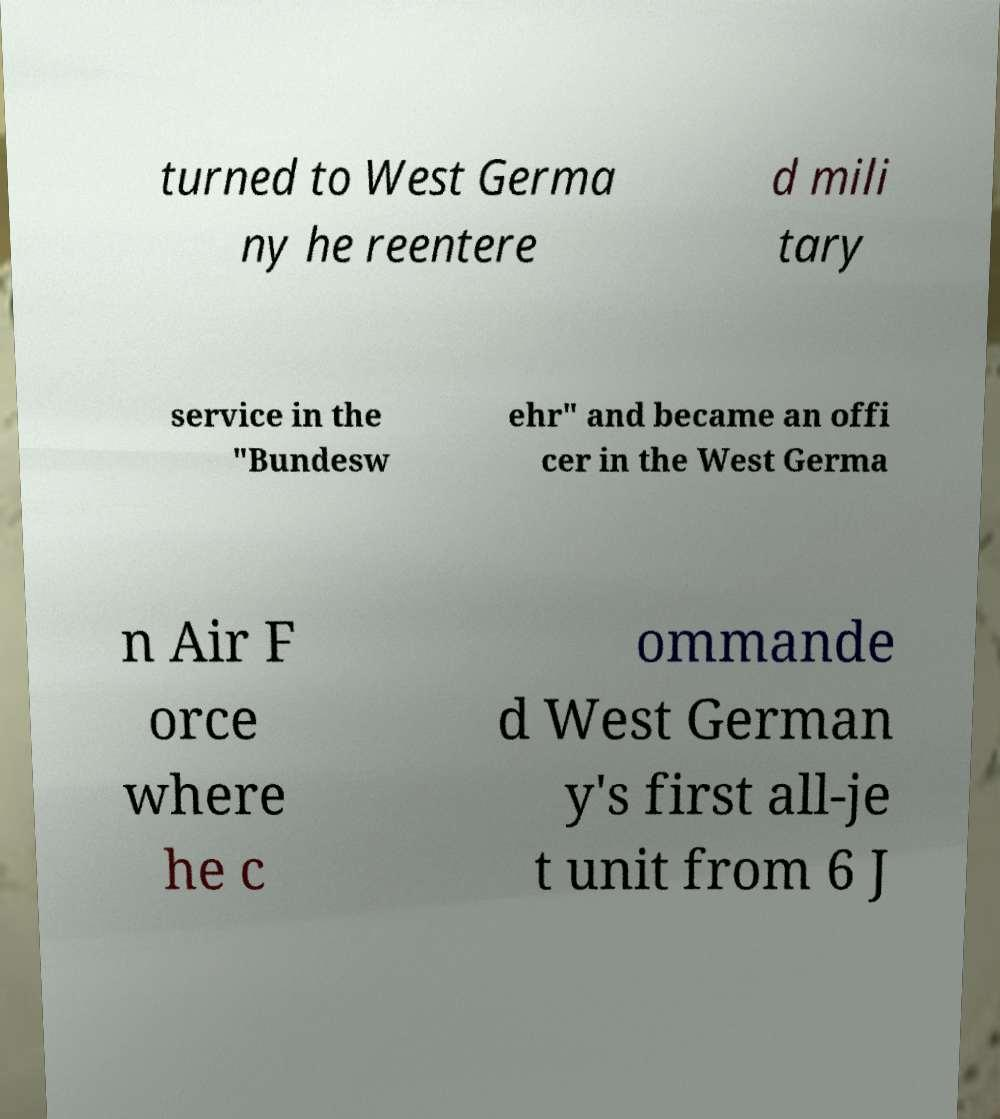What messages or text are displayed in this image? I need them in a readable, typed format. turned to West Germa ny he reentere d mili tary service in the "Bundesw ehr" and became an offi cer in the West Germa n Air F orce where he c ommande d West German y's first all-je t unit from 6 J 